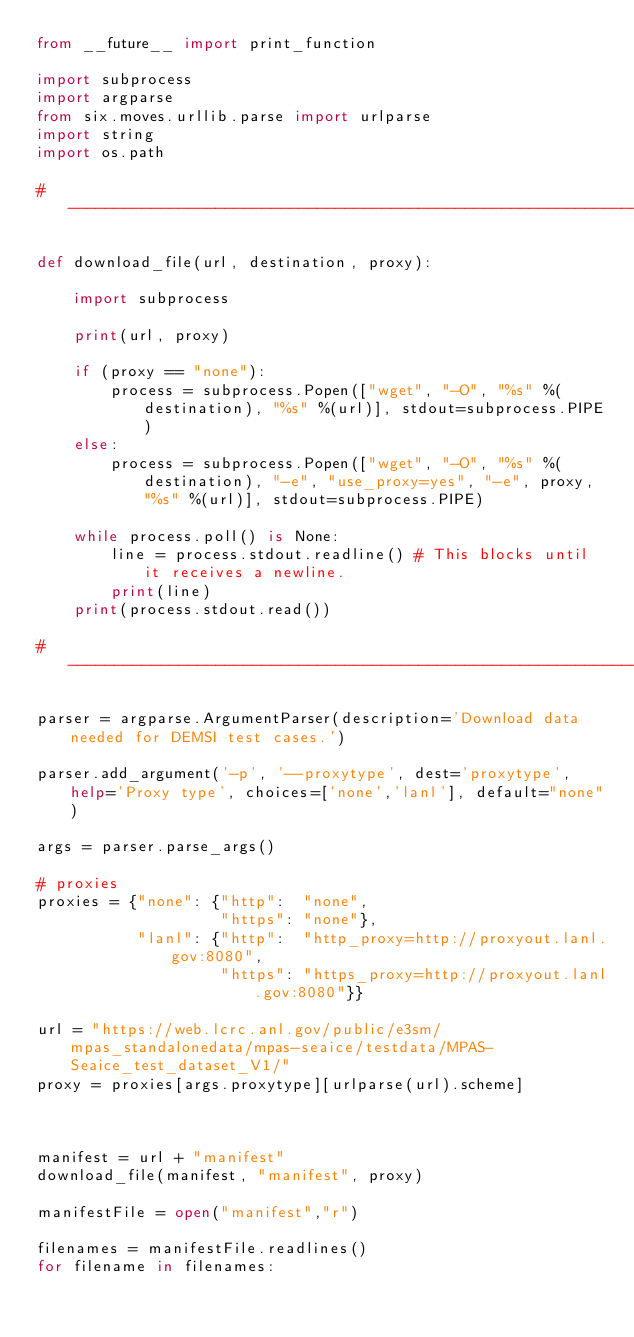<code> <loc_0><loc_0><loc_500><loc_500><_Python_>from __future__ import print_function

import subprocess
import argparse
from six.moves.urllib.parse import urlparse
import string
import os.path

#-------------------------------------------------------------------------------

def download_file(url, destination, proxy):

    import subprocess

    print(url, proxy)

    if (proxy == "none"):
        process = subprocess.Popen(["wget", "-O", "%s" %(destination), "%s" %(url)], stdout=subprocess.PIPE)
    else:
        process = subprocess.Popen(["wget", "-O", "%s" %(destination), "-e", "use_proxy=yes", "-e", proxy, "%s" %(url)], stdout=subprocess.PIPE)

    while process.poll() is None:
        line = process.stdout.readline() # This blocks until it receives a newline.
        print(line)
    print(process.stdout.read())

#-------------------------------------------------------------------------------

parser = argparse.ArgumentParser(description='Download data needed for DEMSI test cases.')

parser.add_argument('-p', '--proxytype', dest='proxytype', help='Proxy type', choices=['none','lanl'], default="none")

args = parser.parse_args()

# proxies
proxies = {"none": {"http":  "none",
                    "https": "none"},
           "lanl": {"http":  "http_proxy=http://proxyout.lanl.gov:8080",
                    "https": "https_proxy=http://proxyout.lanl.gov:8080"}}

url = "https://web.lcrc.anl.gov/public/e3sm/mpas_standalonedata/mpas-seaice/testdata/MPAS-Seaice_test_dataset_V1/"
proxy = proxies[args.proxytype][urlparse(url).scheme]



manifest = url + "manifest"
download_file(manifest, "manifest", proxy)

manifestFile = open("manifest","r")

filenames = manifestFile.readlines()
for filename in filenames:</code> 